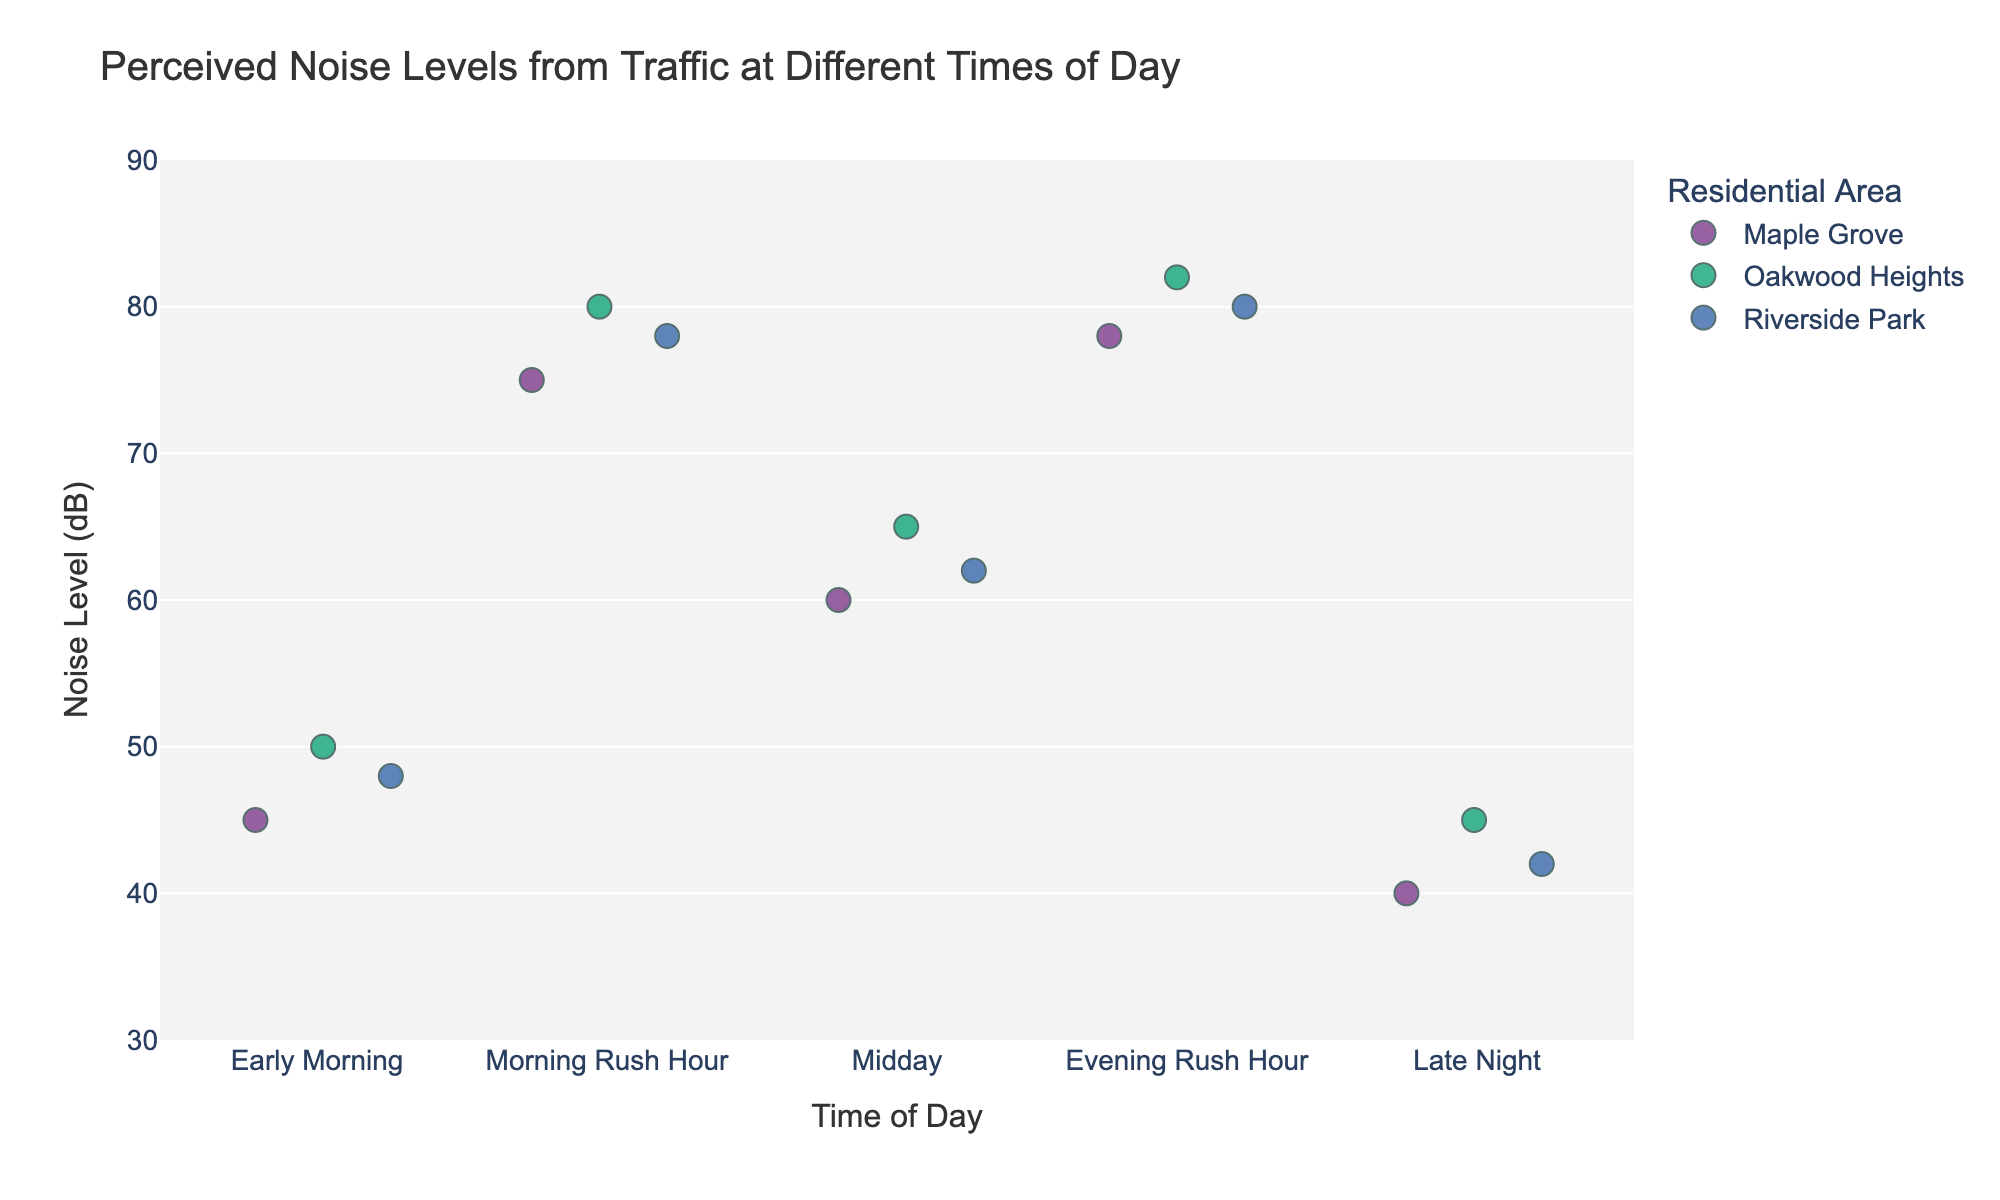What's the highest perceived noise level during the Morning Rush Hour? The highest perceived noise level is represented by the data point at the uppermost horizontal position in the Morning Rush Hour group. The value can be identified as 80 dB at Oakwood Heights.
Answer: 80 dB Which Residential Area has the highest perceived noise level during the Evening Rush Hour? By comparing the data points in the Evening Rush Hour group, the highest perceived noise level can be identified at Oakwood Heights, which is 82 dB.
Answer: Oakwood Heights How do the perceived noise levels during the Morning Rush Hour compare to those in the Evening Rush Hour? By observing the spread and upper bounds of the noise levels for both the Morning Rush Hour and Evening Rush Hour, we can see that they are quite similar, with both times showing high values in the range of 75-82 dB.
Answer: Similar What is the average perceived noise level in Riverside Park during the Midday? To find the average, sum the noise levels in Riverside Park during the Midday (62 dB) and divide by the number of data points (1). Therefore, the average is 62.
Answer: 62 dB Which time of day has the lowest perceived noise level recorded? By looking at the position of the lowest data point across the x-axis, the Early Morning and Late Night have the lowest perceived noise levels, both around 40-42 dB.
Answer: Early Morning and Late Night What's the difference in noise levels between the highest and lowest times of day in Maple Grove? The highest perceived noise level in Maple Grove is during the Evening Rush Hour (78 dB), and the lowest is in the Late Night (40 dB). The difference is 78 - 40 = 38 dB.
Answer: 38 dB Which Residential Area shows the most consistent perceived noise levels throughout the day? Consistency can be gauged by the spread of data points for each Residential Area. Maple Grove shows relatively smaller variation compared to Oakwood Heights and Riverside Park, making it more consistent.
Answer: Maple Grove Is there a time of day where all residential areas have perceived noise levels above 75 dB? By examining the noise levels for each time of day, during both Morning Rush Hour and Evening Rush Hour, all residential areas have noise levels above 75 dB.
Answer: Yes From the figure, which time of day has the most varied perceived noise levels? Varied noise levels can be observed by the spread of data points. The Evening Rush Hour shows the spread from 78 dB to 82 dB, indicating the most variation.
Answer: Evening Rush Hour Can we identify a correlation between the time of day and noise levels from the strip plot? Observing the overall pattern, there is a clear trend showing higher noise levels during rush hours (Morning and Evening) and lower noise levels at Early Morning and Late Night.
Answer: Yes 